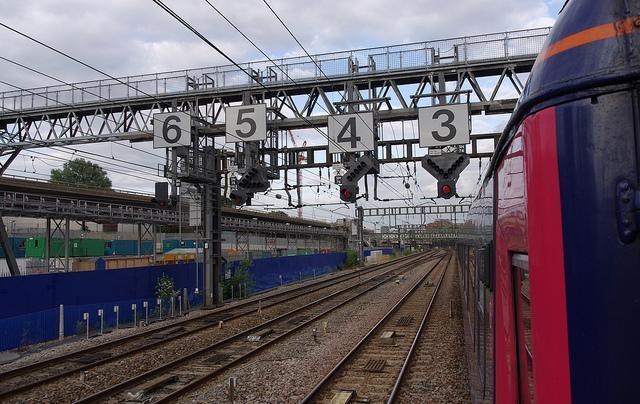How many trees are in the picture?
Give a very brief answer. 1. 